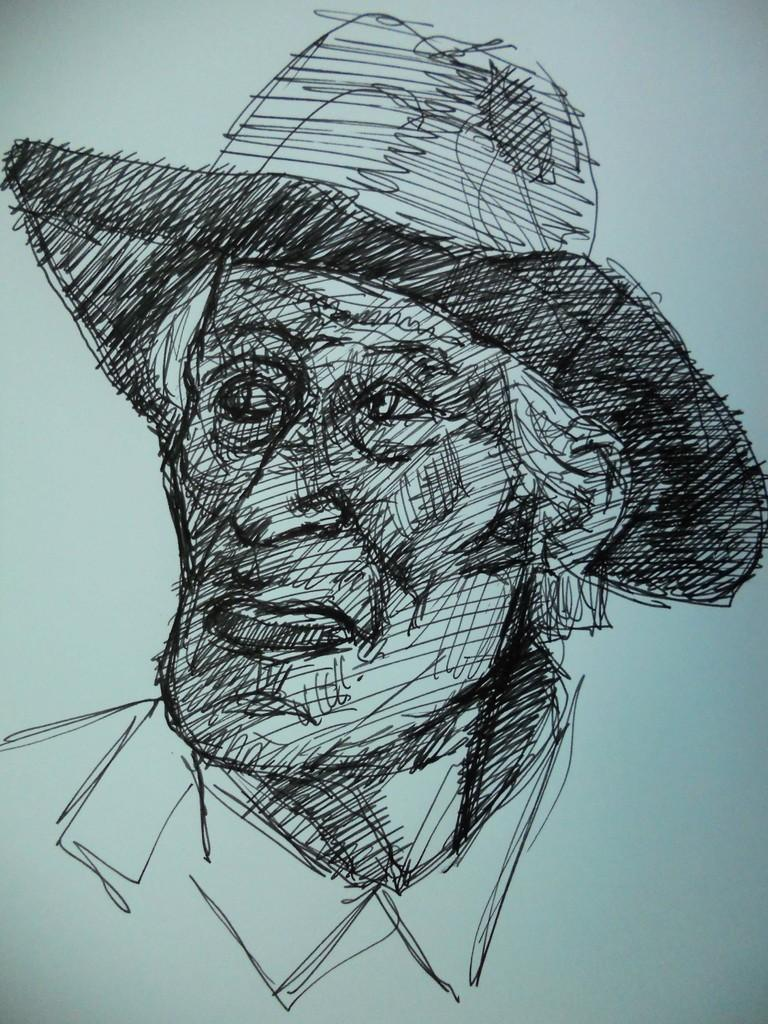What is the main subject of the sketch in the image? The main subject of the sketch in the image is a person. What accessory is the person in the sketch wearing? The person in the sketch is wearing a hat. How many girls are present in the sketch in the image? There is no mention of girls in the image, as the sketch features a person wearing a hat. 